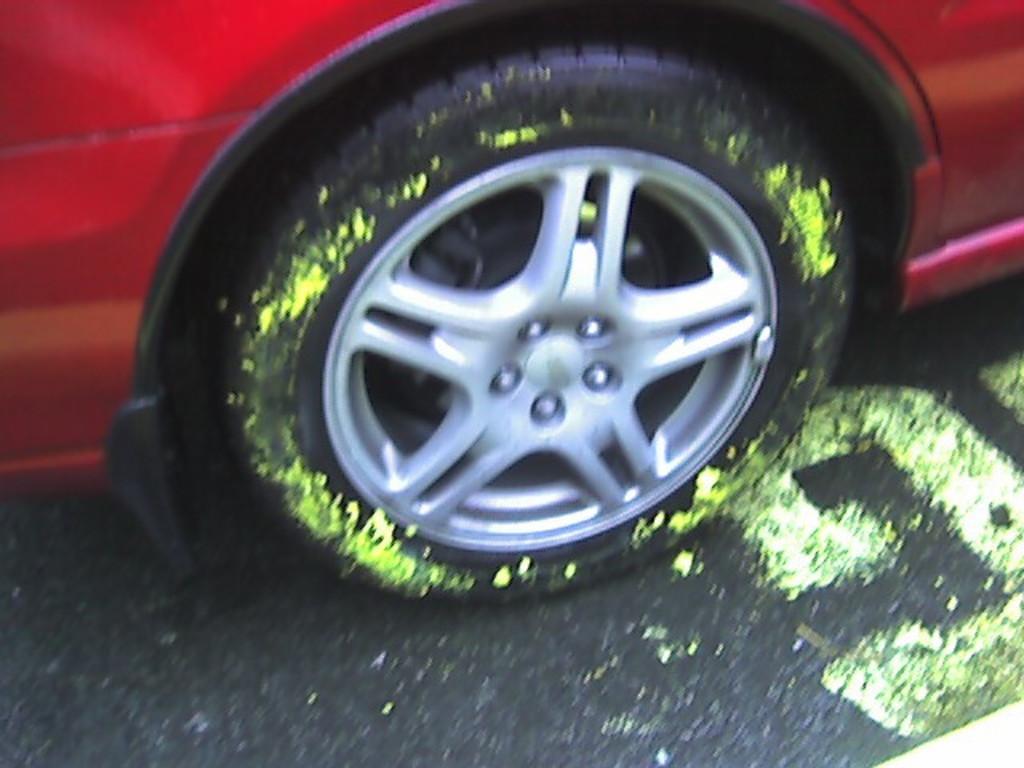Could you give a brief overview of what you see in this image? In this picture there is a red color car on the road. On the wheel I can see the green paint. 